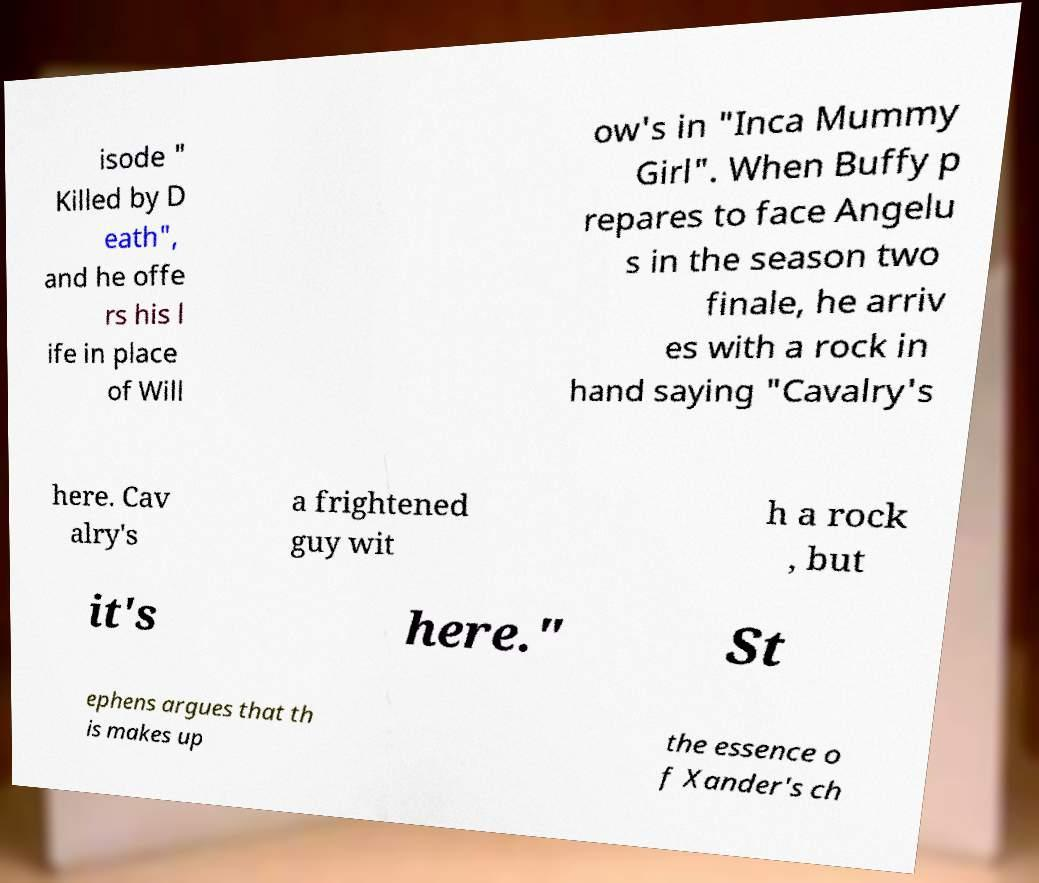I need the written content from this picture converted into text. Can you do that? isode " Killed by D eath", and he offe rs his l ife in place of Will ow's in "Inca Mummy Girl". When Buffy p repares to face Angelu s in the season two finale, he arriv es with a rock in hand saying "Cavalry's here. Cav alry's a frightened guy wit h a rock , but it's here." St ephens argues that th is makes up the essence o f Xander's ch 